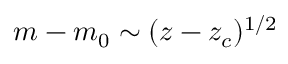<formula> <loc_0><loc_0><loc_500><loc_500>m - m _ { 0 } \sim ( z - z _ { c } ) ^ { 1 / 2 }</formula> 